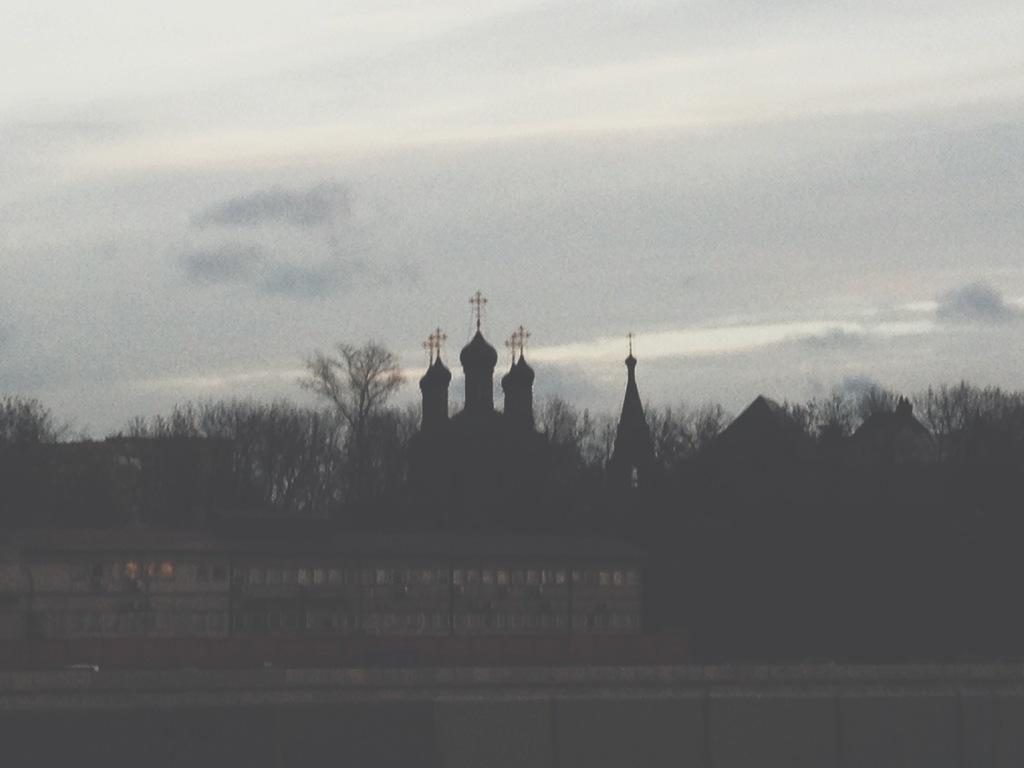What type of building is in the image? There is a church in the image. What other natural elements can be seen in the image? There are trees in the image. What is visible in the background of the image? The sky is visible in the background of the image. How many screws can be seen on the church in the image? There are no screws visible on the church in the image. What type of road is present in the image? There is no road present in the image; it features a church and trees. 